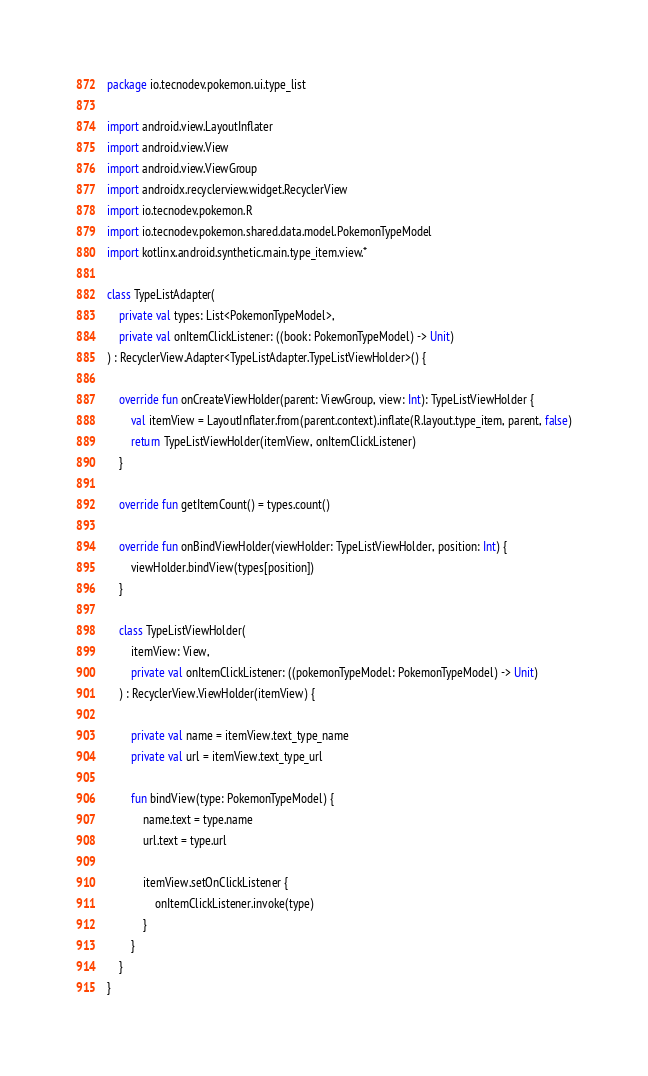<code> <loc_0><loc_0><loc_500><loc_500><_Kotlin_>package io.tecnodev.pokemon.ui.type_list

import android.view.LayoutInflater
import android.view.View
import android.view.ViewGroup
import androidx.recyclerview.widget.RecyclerView
import io.tecnodev.pokemon.R
import io.tecnodev.pokemon.shared.data.model.PokemonTypeModel
import kotlinx.android.synthetic.main.type_item.view.*

class TypeListAdapter(
    private val types: List<PokemonTypeModel>,
    private val onItemClickListener: ((book: PokemonTypeModel) -> Unit)
) : RecyclerView.Adapter<TypeListAdapter.TypeListViewHolder>() {

    override fun onCreateViewHolder(parent: ViewGroup, view: Int): TypeListViewHolder {
        val itemView = LayoutInflater.from(parent.context).inflate(R.layout.type_item, parent, false)
        return TypeListViewHolder(itemView, onItemClickListener)
    }

    override fun getItemCount() = types.count()

    override fun onBindViewHolder(viewHolder: TypeListViewHolder, position: Int) {
        viewHolder.bindView(types[position])
    }

    class TypeListViewHolder(
        itemView: View,
        private val onItemClickListener: ((pokemonTypeModel: PokemonTypeModel) -> Unit)
    ) : RecyclerView.ViewHolder(itemView) {

        private val name = itemView.text_type_name
        private val url = itemView.text_type_url

        fun bindView(type: PokemonTypeModel) {
            name.text = type.name
            url.text = type.url

            itemView.setOnClickListener {
                onItemClickListener.invoke(type)
            }
        }
    }
}</code> 